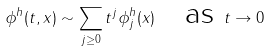Convert formula to latex. <formula><loc_0><loc_0><loc_500><loc_500>\phi ^ { h } ( t , x ) \sim \sum _ { j \geq 0 } t ^ { j } \phi ^ { h } _ { j } ( x ) \quad \text {as } t \to 0</formula> 